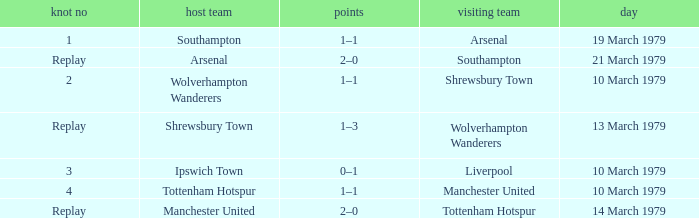What was the score for the tie that had Shrewsbury Town as home team? 1–3. 